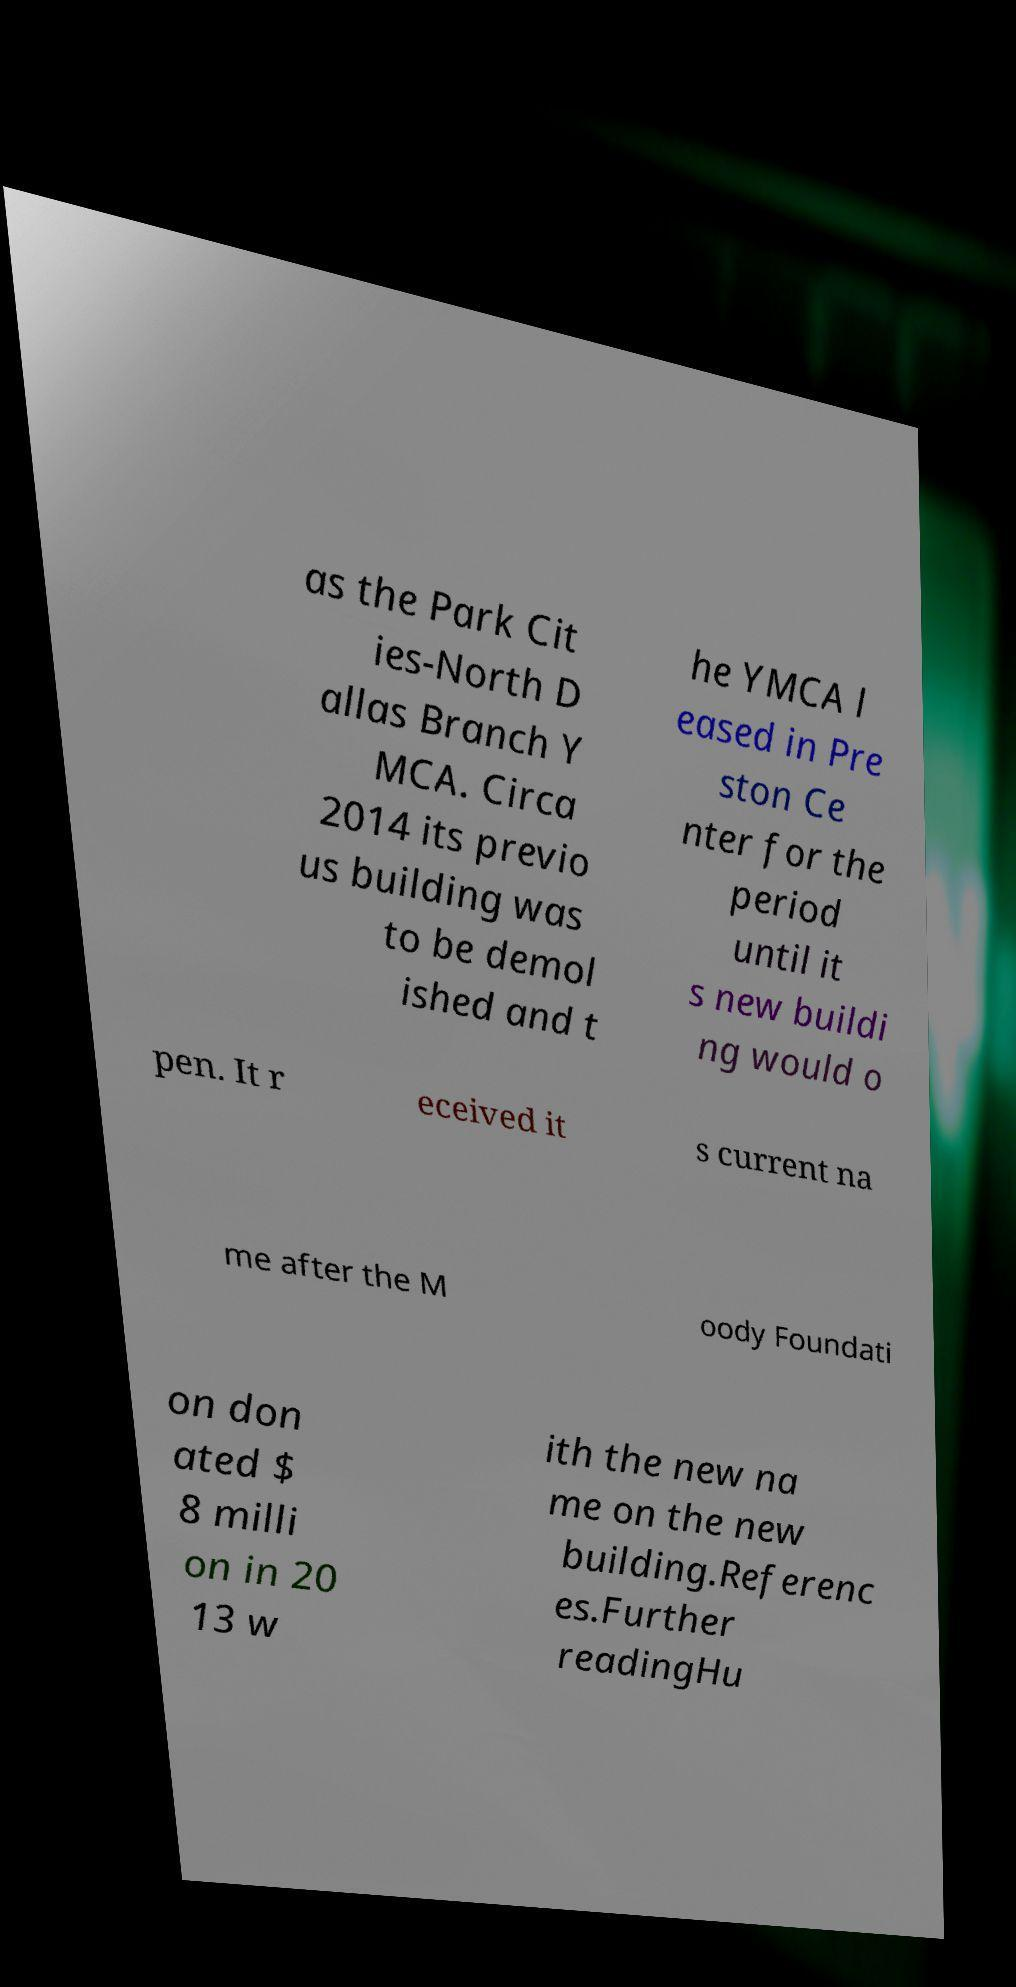Can you read and provide the text displayed in the image?This photo seems to have some interesting text. Can you extract and type it out for me? as the Park Cit ies-North D allas Branch Y MCA. Circa 2014 its previo us building was to be demol ished and t he YMCA l eased in Pre ston Ce nter for the period until it s new buildi ng would o pen. It r eceived it s current na me after the M oody Foundati on don ated $ 8 milli on in 20 13 w ith the new na me on the new building.Referenc es.Further readingHu 